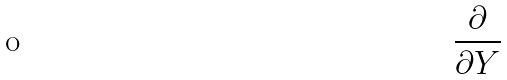Convert formula to latex. <formula><loc_0><loc_0><loc_500><loc_500>\frac { \partial } { \partial Y }</formula> 